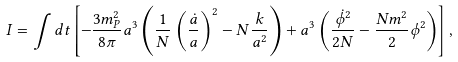Convert formula to latex. <formula><loc_0><loc_0><loc_500><loc_500>I = \int d t \left [ - \frac { 3 m _ { P } ^ { 2 } } { 8 \pi } a ^ { 3 } \left ( \frac { 1 } { N } \left ( \frac { \dot { a } } { a } \right ) ^ { 2 } - N \frac { k } { a ^ { 2 } } \right ) + a ^ { 3 } \left ( \frac { \dot { \phi } ^ { 2 } } { 2 N } - \frac { N m ^ { 2 } } { 2 } \phi ^ { 2 } \right ) \right ] ,</formula> 